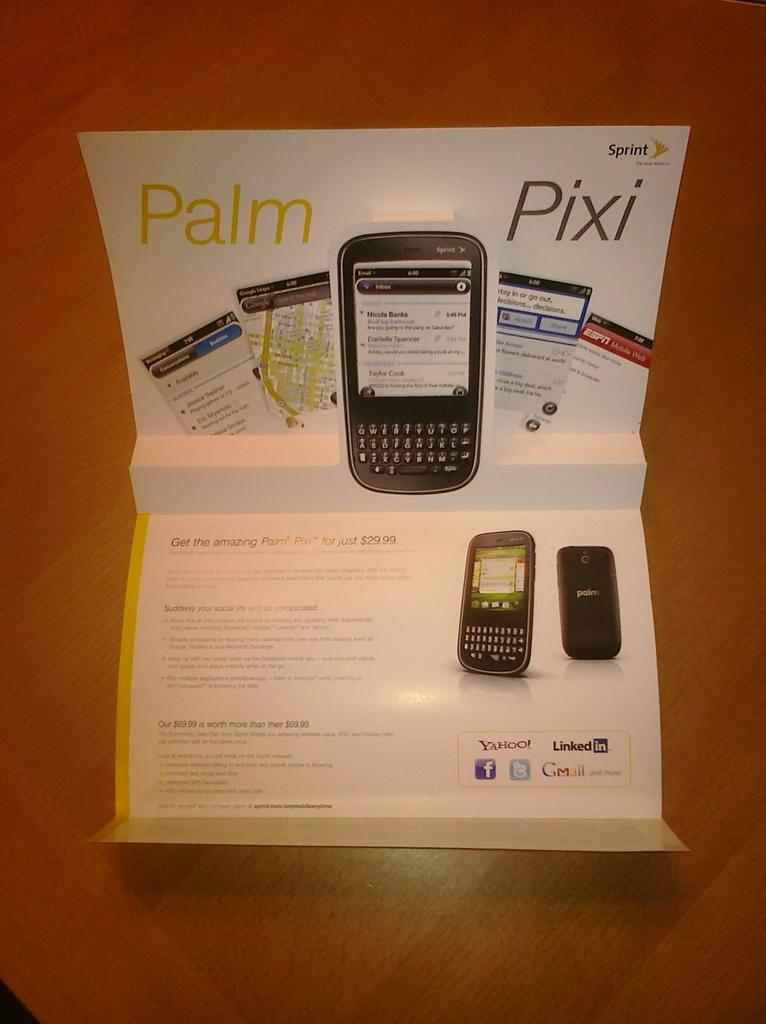<image>
Summarize the visual content of the image. a booklet with the word pixi on it 